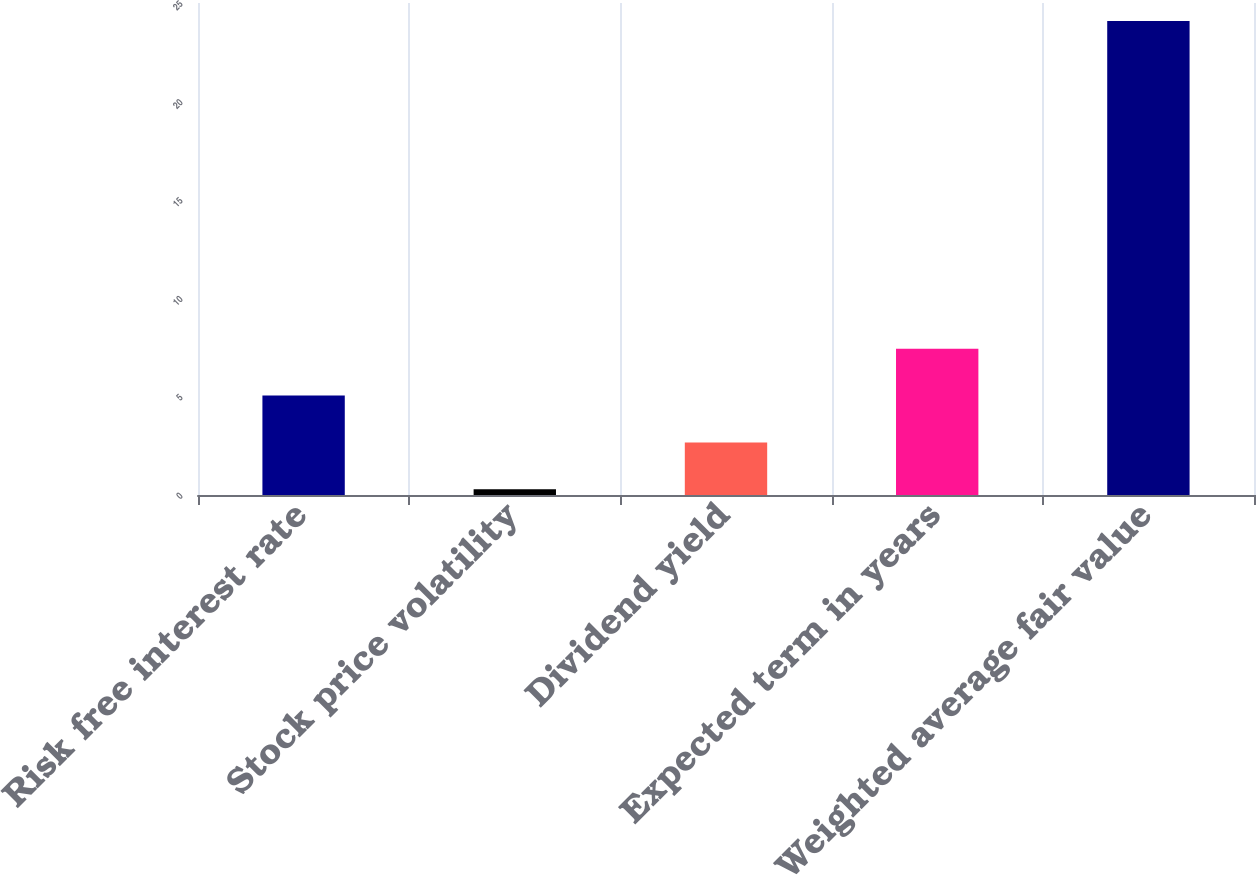<chart> <loc_0><loc_0><loc_500><loc_500><bar_chart><fcel>Risk free interest rate<fcel>Stock price volatility<fcel>Dividend yield<fcel>Expected term in years<fcel>Weighted average fair value<nl><fcel>5.05<fcel>0.29<fcel>2.67<fcel>7.43<fcel>24.09<nl></chart> 